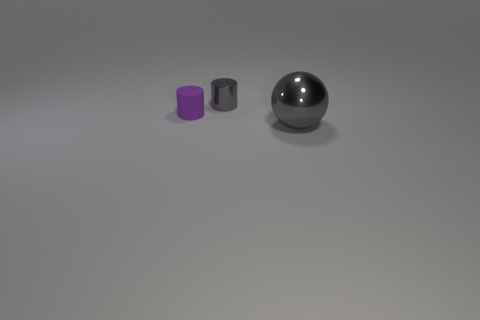Add 1 large gray metallic things. How many objects exist? 4 Subtract 1 cylinders. How many cylinders are left? 1 Subtract all cylinders. How many objects are left? 1 Subtract all brown spheres. Subtract all blue cylinders. How many spheres are left? 1 Subtract all brown balls. How many cyan cylinders are left? 0 Subtract all large shiny blocks. Subtract all gray metallic things. How many objects are left? 1 Add 2 tiny gray things. How many tiny gray things are left? 3 Add 2 tiny purple matte cylinders. How many tiny purple matte cylinders exist? 3 Subtract 1 purple cylinders. How many objects are left? 2 